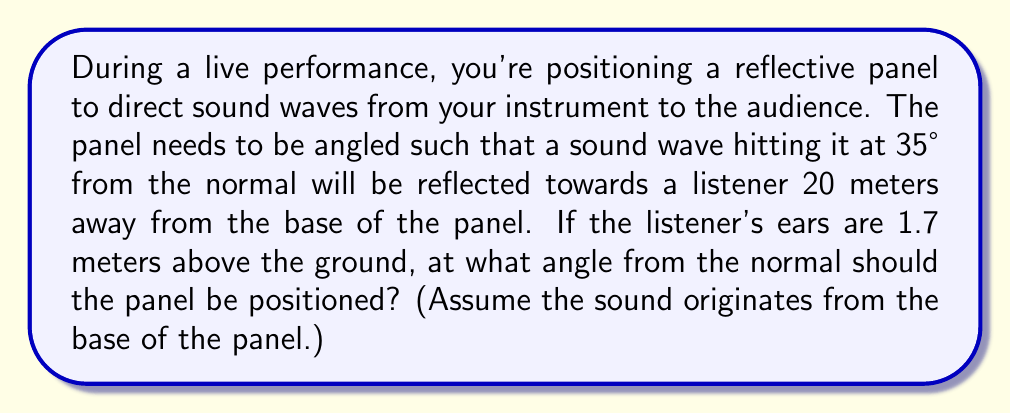Teach me how to tackle this problem. Let's approach this step-by-step:

1) First, recall the law of reflection: the angle of incidence equals the angle of reflection. If the incoming wave is 35° from the normal, the reflected wave will also be 35° from the normal on the other side.

2) Let's define our variables:
   $\theta$ = angle we're looking for (panel angle from normal)
   $h$ = height of listener's ears = 1.7 m
   $d$ = distance of listener from panel base = 20 m

3) We can create a right triangle where:
   - The hypotenuse is the path of the reflected sound wave
   - The opposite side is the height of the listener's ears (1.7 m)
   - The adjacent side is the distance to the listener (20 m)

4) We can find the angle of this triangle using the tangent function:

   $$\tan(\theta) = \frac{\text{opposite}}{\text{adjacent}} = \frac{1.7}{20}$$

5) To solve for $\theta$, we use the inverse tangent (arctangent):

   $$\theta = \tan^{-1}(\frac{1.7}{20})$$

6) Using a calculator or computer:

   $$\theta \approx 4.85°$$

7) Remember, this is the angle of the reflected wave from the normal. The panel needs to be positioned halfway between the incident wave (35°) and this reflected wave.

8) The final angle for the panel is:

   $$\text{Panel angle} = \frac{35° + 4.85°}{2} \approx 19.93°$$
Answer: $19.93°$ 